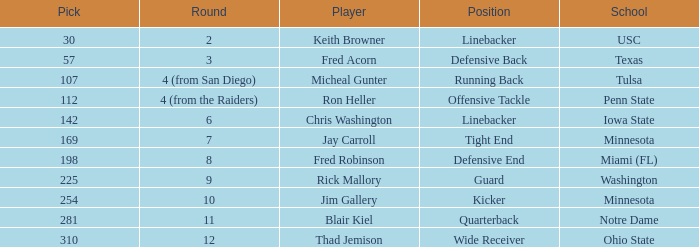What is the selection number of penn state? 112.0. 